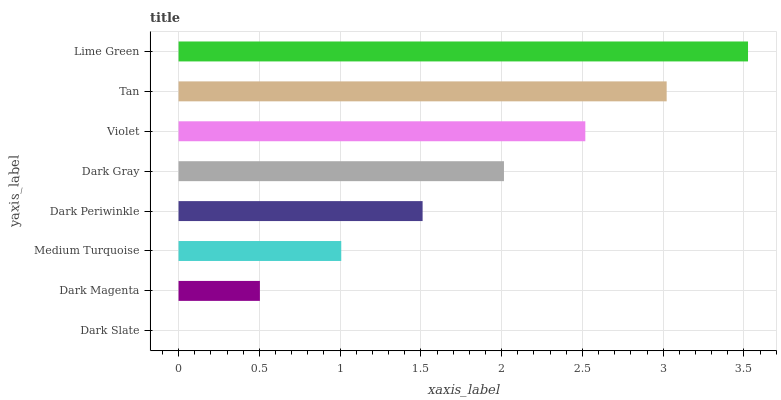Is Dark Slate the minimum?
Answer yes or no. Yes. Is Lime Green the maximum?
Answer yes or no. Yes. Is Dark Magenta the minimum?
Answer yes or no. No. Is Dark Magenta the maximum?
Answer yes or no. No. Is Dark Magenta greater than Dark Slate?
Answer yes or no. Yes. Is Dark Slate less than Dark Magenta?
Answer yes or no. Yes. Is Dark Slate greater than Dark Magenta?
Answer yes or no. No. Is Dark Magenta less than Dark Slate?
Answer yes or no. No. Is Dark Gray the high median?
Answer yes or no. Yes. Is Dark Periwinkle the low median?
Answer yes or no. Yes. Is Tan the high median?
Answer yes or no. No. Is Tan the low median?
Answer yes or no. No. 